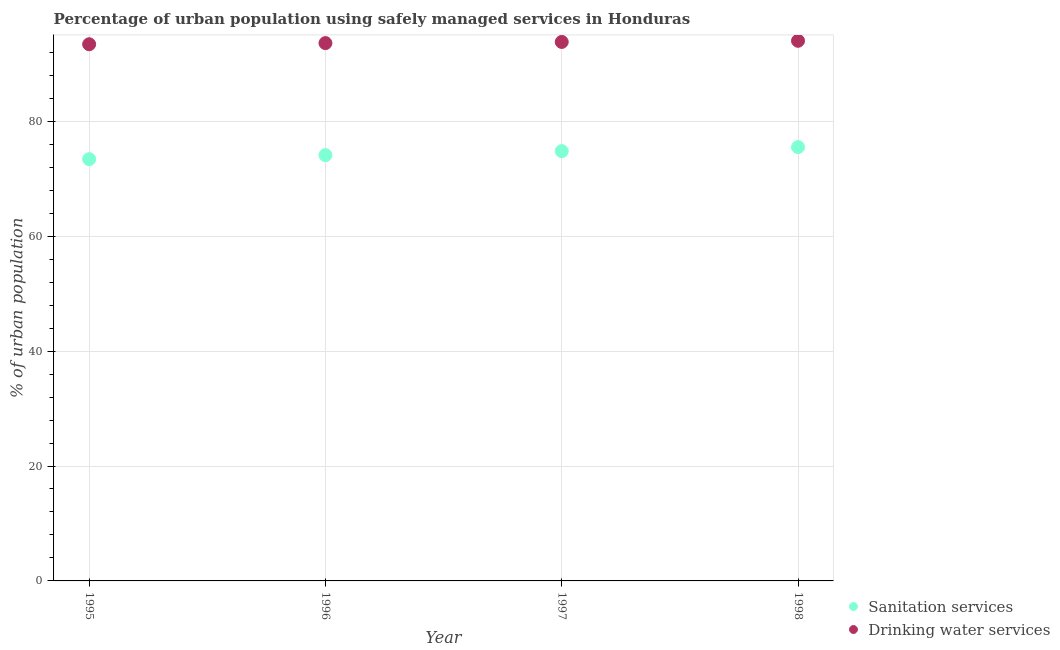How many different coloured dotlines are there?
Make the answer very short. 2. What is the percentage of urban population who used sanitation services in 1996?
Provide a succinct answer. 74.1. Across all years, what is the maximum percentage of urban population who used sanitation services?
Make the answer very short. 75.5. Across all years, what is the minimum percentage of urban population who used sanitation services?
Your answer should be compact. 73.4. In which year was the percentage of urban population who used drinking water services minimum?
Ensure brevity in your answer.  1995. What is the total percentage of urban population who used drinking water services in the graph?
Your answer should be compact. 374.8. What is the difference between the percentage of urban population who used drinking water services in 1997 and that in 1998?
Give a very brief answer. -0.2. What is the difference between the percentage of urban population who used drinking water services in 1997 and the percentage of urban population who used sanitation services in 1998?
Provide a succinct answer. 18.3. What is the average percentage of urban population who used sanitation services per year?
Keep it short and to the point. 74.45. What is the ratio of the percentage of urban population who used sanitation services in 1995 to that in 1996?
Your answer should be very brief. 0.99. What is the difference between the highest and the second highest percentage of urban population who used sanitation services?
Offer a very short reply. 0.7. What is the difference between the highest and the lowest percentage of urban population who used drinking water services?
Provide a succinct answer. 0.6. How many dotlines are there?
Provide a short and direct response. 2. How many years are there in the graph?
Provide a short and direct response. 4. What is the difference between two consecutive major ticks on the Y-axis?
Keep it short and to the point. 20. Are the values on the major ticks of Y-axis written in scientific E-notation?
Make the answer very short. No. Does the graph contain any zero values?
Provide a short and direct response. No. How many legend labels are there?
Your response must be concise. 2. What is the title of the graph?
Offer a terse response. Percentage of urban population using safely managed services in Honduras. What is the label or title of the X-axis?
Keep it short and to the point. Year. What is the label or title of the Y-axis?
Provide a succinct answer. % of urban population. What is the % of urban population of Sanitation services in 1995?
Offer a terse response. 73.4. What is the % of urban population in Drinking water services in 1995?
Give a very brief answer. 93.4. What is the % of urban population of Sanitation services in 1996?
Your response must be concise. 74.1. What is the % of urban population of Drinking water services in 1996?
Keep it short and to the point. 93.6. What is the % of urban population of Sanitation services in 1997?
Ensure brevity in your answer.  74.8. What is the % of urban population of Drinking water services in 1997?
Your answer should be very brief. 93.8. What is the % of urban population of Sanitation services in 1998?
Make the answer very short. 75.5. What is the % of urban population of Drinking water services in 1998?
Offer a very short reply. 94. Across all years, what is the maximum % of urban population of Sanitation services?
Offer a very short reply. 75.5. Across all years, what is the maximum % of urban population in Drinking water services?
Provide a short and direct response. 94. Across all years, what is the minimum % of urban population in Sanitation services?
Your response must be concise. 73.4. Across all years, what is the minimum % of urban population in Drinking water services?
Your answer should be compact. 93.4. What is the total % of urban population in Sanitation services in the graph?
Make the answer very short. 297.8. What is the total % of urban population in Drinking water services in the graph?
Your answer should be compact. 374.8. What is the difference between the % of urban population of Sanitation services in 1995 and that in 1996?
Offer a terse response. -0.7. What is the difference between the % of urban population of Drinking water services in 1995 and that in 1997?
Keep it short and to the point. -0.4. What is the difference between the % of urban population of Drinking water services in 1995 and that in 1998?
Your answer should be very brief. -0.6. What is the difference between the % of urban population in Sanitation services in 1996 and that in 1997?
Your answer should be very brief. -0.7. What is the difference between the % of urban population of Drinking water services in 1996 and that in 1997?
Your answer should be compact. -0.2. What is the difference between the % of urban population in Sanitation services in 1996 and that in 1998?
Offer a very short reply. -1.4. What is the difference between the % of urban population of Sanitation services in 1997 and that in 1998?
Your answer should be compact. -0.7. What is the difference between the % of urban population in Drinking water services in 1997 and that in 1998?
Provide a succinct answer. -0.2. What is the difference between the % of urban population of Sanitation services in 1995 and the % of urban population of Drinking water services in 1996?
Offer a very short reply. -20.2. What is the difference between the % of urban population of Sanitation services in 1995 and the % of urban population of Drinking water services in 1997?
Offer a terse response. -20.4. What is the difference between the % of urban population of Sanitation services in 1995 and the % of urban population of Drinking water services in 1998?
Give a very brief answer. -20.6. What is the difference between the % of urban population in Sanitation services in 1996 and the % of urban population in Drinking water services in 1997?
Your answer should be very brief. -19.7. What is the difference between the % of urban population in Sanitation services in 1996 and the % of urban population in Drinking water services in 1998?
Your answer should be very brief. -19.9. What is the difference between the % of urban population of Sanitation services in 1997 and the % of urban population of Drinking water services in 1998?
Your answer should be compact. -19.2. What is the average % of urban population of Sanitation services per year?
Your answer should be very brief. 74.45. What is the average % of urban population of Drinking water services per year?
Your answer should be very brief. 93.7. In the year 1996, what is the difference between the % of urban population of Sanitation services and % of urban population of Drinking water services?
Provide a succinct answer. -19.5. In the year 1998, what is the difference between the % of urban population of Sanitation services and % of urban population of Drinking water services?
Offer a very short reply. -18.5. What is the ratio of the % of urban population in Sanitation services in 1995 to that in 1996?
Offer a very short reply. 0.99. What is the ratio of the % of urban population in Drinking water services in 1995 to that in 1996?
Give a very brief answer. 1. What is the ratio of the % of urban population in Sanitation services in 1995 to that in 1997?
Keep it short and to the point. 0.98. What is the ratio of the % of urban population of Drinking water services in 1995 to that in 1997?
Provide a short and direct response. 1. What is the ratio of the % of urban population in Sanitation services in 1995 to that in 1998?
Ensure brevity in your answer.  0.97. What is the ratio of the % of urban population in Drinking water services in 1995 to that in 1998?
Make the answer very short. 0.99. What is the ratio of the % of urban population of Sanitation services in 1996 to that in 1997?
Keep it short and to the point. 0.99. What is the ratio of the % of urban population of Sanitation services in 1996 to that in 1998?
Give a very brief answer. 0.98. What is the ratio of the % of urban population in Sanitation services in 1997 to that in 1998?
Provide a short and direct response. 0.99. What is the difference between the highest and the second highest % of urban population of Sanitation services?
Your response must be concise. 0.7. What is the difference between the highest and the second highest % of urban population of Drinking water services?
Offer a very short reply. 0.2. 